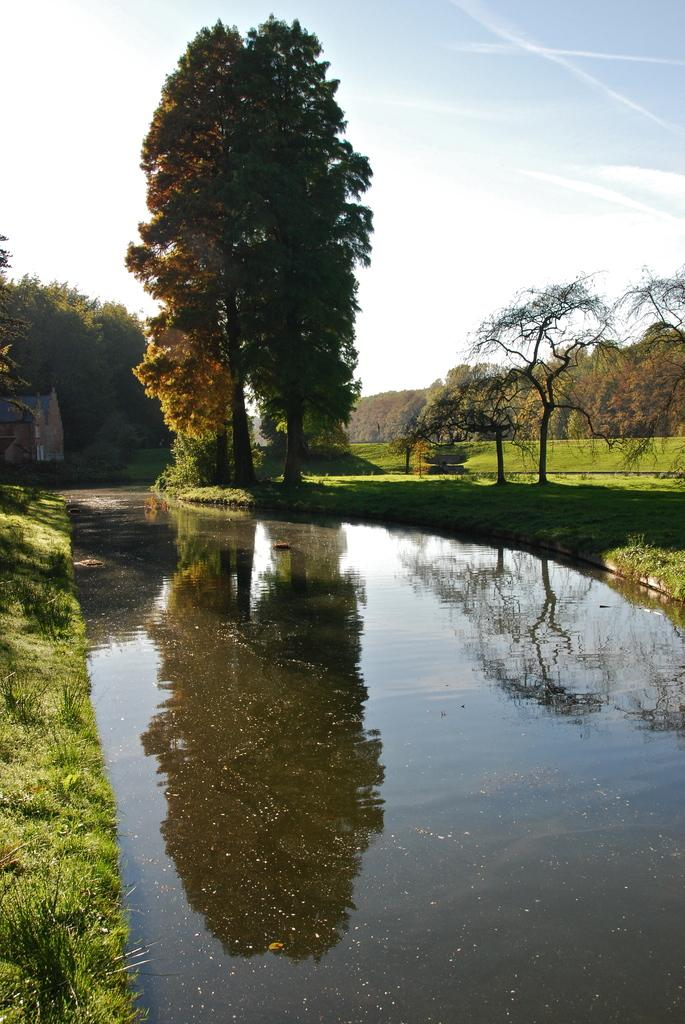What type of natural environment is depicted in the image? The image contains grass, water, and trees, which are elements of a natural environment. What type of structure can be seen in the image? There is a house in the image. What is visible in the background of the image? The sky is visible in the background of the image. How many planes are parked on the floor in the image? There are no planes or floors present in the image; it features a natural environment with grass, water, trees, and a house. 